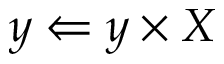Convert formula to latex. <formula><loc_0><loc_0><loc_500><loc_500>y \Leftarrow y \times X</formula> 